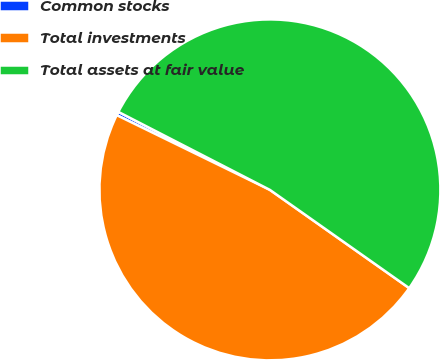Convert chart. <chart><loc_0><loc_0><loc_500><loc_500><pie_chart><fcel>Common stocks<fcel>Total investments<fcel>Total assets at fair value<nl><fcel>0.34%<fcel>47.45%<fcel>52.21%<nl></chart> 